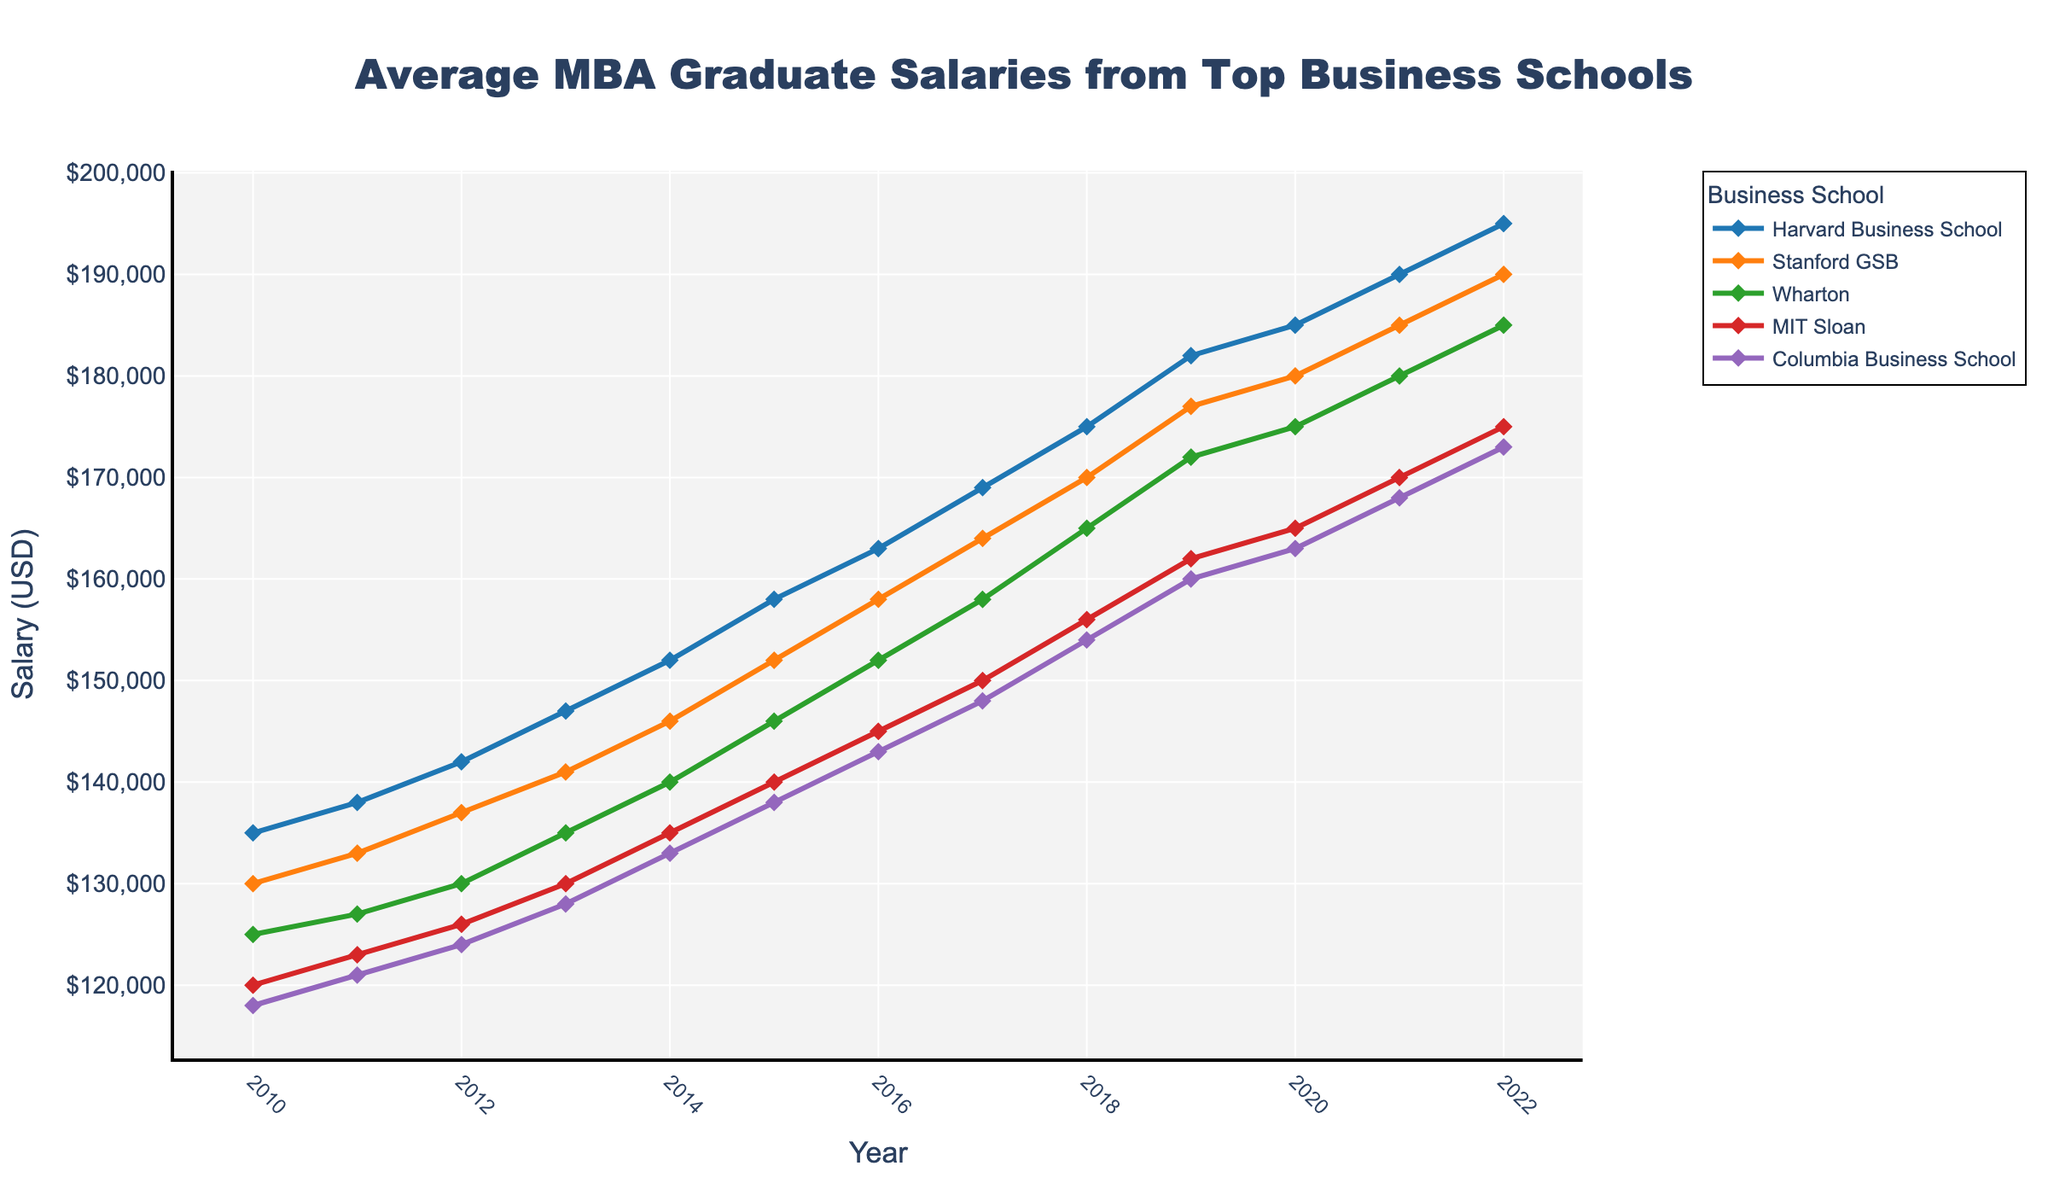Which business school had the highest average salary for MBA graduates in 2022? By reviewing the final set of data points for each school in 2022, we notice that Harvard Business School has the highest salary.
Answer: Harvard Business School Between 2010 and 2022, which school had the greatest increase in average MBA graduate salaries? Calculate the difference in salaries from 2010 to 2022 for each school. Harvard: 195000-135000 = 60000; Stanford: 190000-130000 = 60000; Wharton: 185000-125000 = 60000; MIT Sloan: 175000-120000 = 55000; Columbia: 173000-118000 = 55000. Harvard, Stanford, and Wharton had the highest at 60000.
Answer: Harvard Business School, Stanford GSB, Wharton What was the average salary of MBA graduates across all five schools in 2015? Sum the salaries for 2015 and divide by the number of schools: (158000 + 152000 + 146000 + 140000 + 138000) / 5 = 146800.
Answer: 146800 Which year did Columbia Business School surpass the $150,000 average salary mark for the first time? Observe Columbia Business School data until it first exceeds $150,000. In 2017, it reaches $148000, but in 2018 it is $154000, thus exceeding the $150,000 mark.
Answer: 2018 In 2021, which business school had the smallest difference in salary compared to the previous year? Calculate the difference from 2020 to 2021 for each school. Harvard: 190000-185000 = 5000; Stanford: 185000-180000 = 5000; Wharton: 180000-175000 = 5000; MIT Sloan: 170000-165000 = 5000; Columbia: 168000-163000 = 5000. All schools had the same difference of $5000.
Answer: All schools What is the ratio of the average salary of Harvard MBA graduates in 2022 to the average salary of MIT Sloan MBA graduates in the same year? Divide the salary of Harvard by MIT Sloan in 2022: 195000 / 175000 = 1.114.
Answer: 1.114 Which school showed the largest annual increment in average salaries in any single year throughout the given period? Identify the maximum annual increment for each school and compare: Harvard: max(5000); Stanford: max(5000); Wharton: max(5000); MIT Sloan: max(5000); Columbia Business School: max(5000). The largest of these is $5000, shared by all schools.
Answer: All schools Between 2010 and 2015, what is the sum of average salary increments for Wharton? Calculate the sum of increments for 2010-2015. Wharton: (127000-125000) + (130000-127000) + (135000-130000) + (140000-135000) + (146000-140000) = 2000 + 3000 + 5000 + 5000 + 6000 = 21000.
Answer: 21000 In which year did Stanford GSB first surpass the $150,000 mark in average salaries? Observe the given data points for Stanford GSB until it exceeds $150,000. It first surpasses this amount in 2016 (158000).
Answer: 2016 